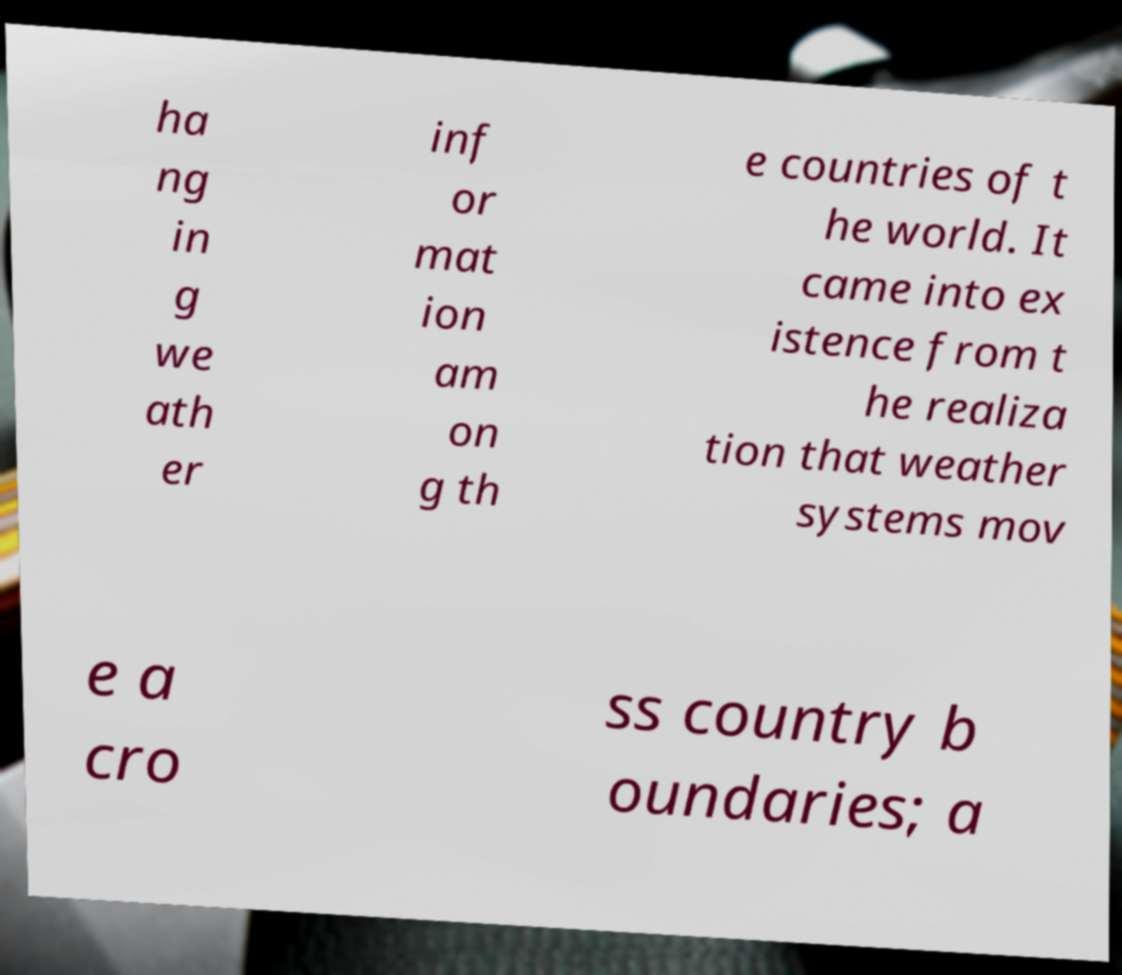Please read and relay the text visible in this image. What does it say? ha ng in g we ath er inf or mat ion am on g th e countries of t he world. It came into ex istence from t he realiza tion that weather systems mov e a cro ss country b oundaries; a 